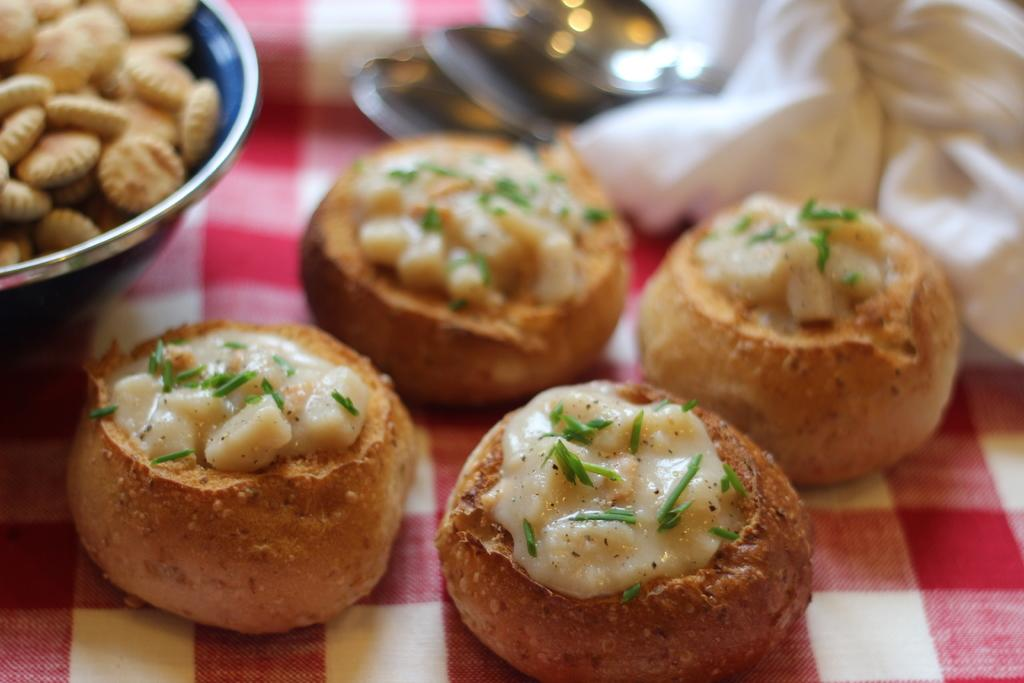What is present in the image that people typically consume? There is food in the image. Can you describe anything visible in the background of the image? There are objects visible in the background of the image. What type of ticket can be seen in the image? There is no ticket present in the image. What kind of cave can be seen in the image? There is no cave present in the image. What type of waves can be seen in the image? There is no reference to waves in the image. 